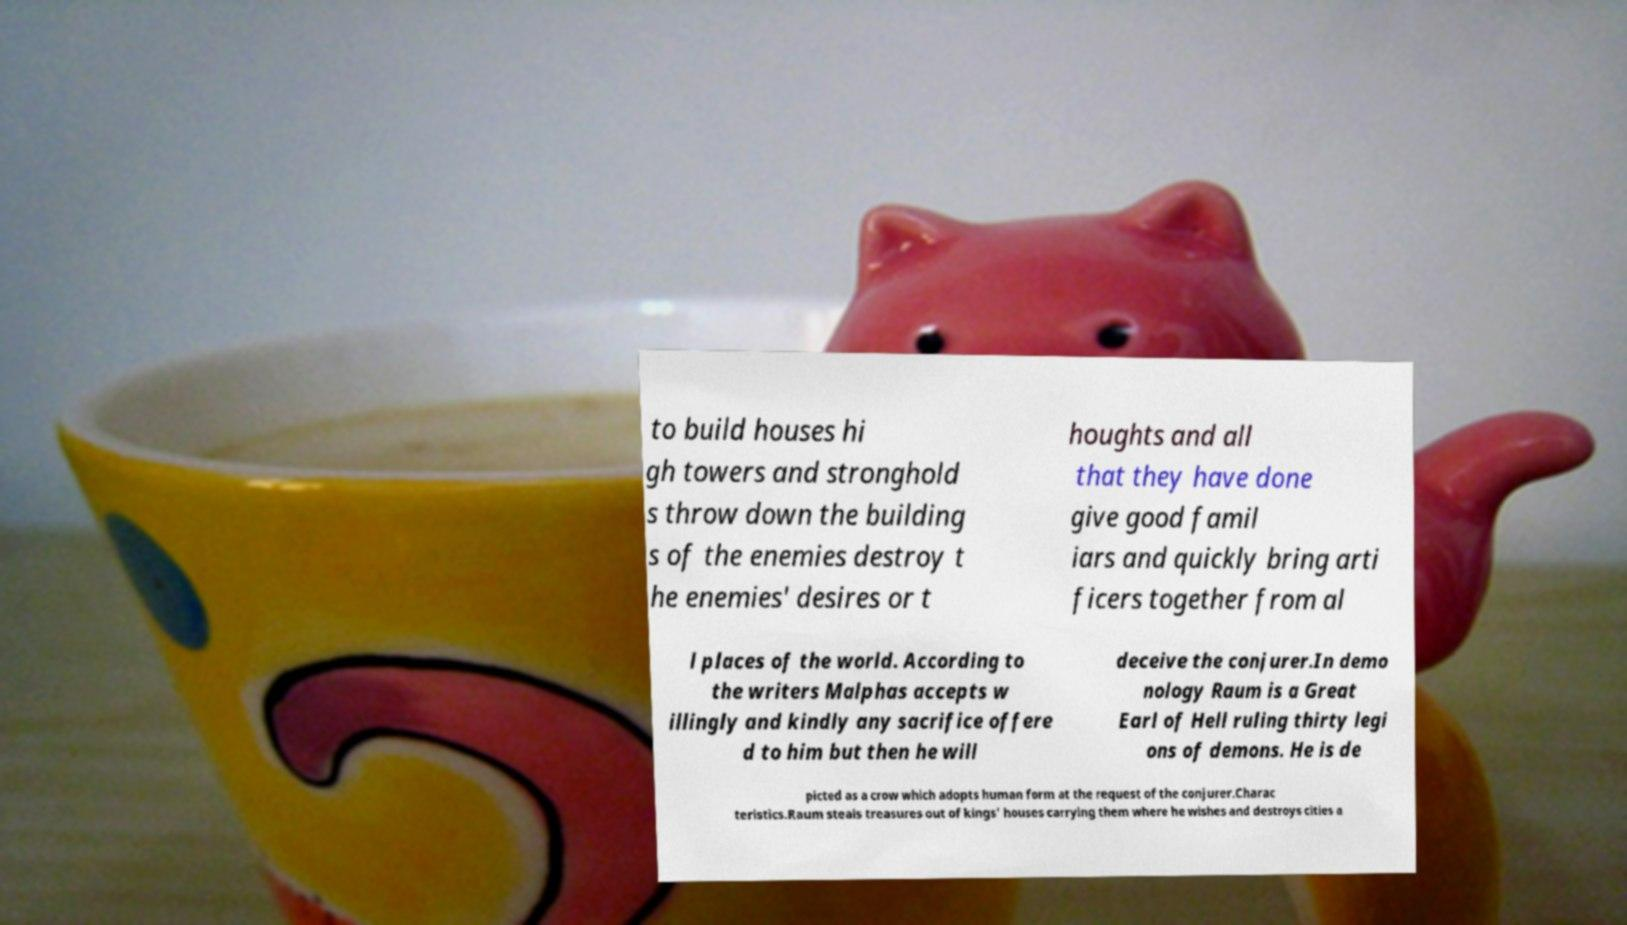What messages or text are displayed in this image? I need them in a readable, typed format. to build houses hi gh towers and stronghold s throw down the building s of the enemies destroy t he enemies' desires or t houghts and all that they have done give good famil iars and quickly bring arti ficers together from al l places of the world. According to the writers Malphas accepts w illingly and kindly any sacrifice offere d to him but then he will deceive the conjurer.In demo nology Raum is a Great Earl of Hell ruling thirty legi ons of demons. He is de picted as a crow which adopts human form at the request of the conjurer.Charac teristics.Raum steals treasures out of kings' houses carrying them where he wishes and destroys cities a 